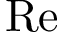<formula> <loc_0><loc_0><loc_500><loc_500>R e</formula> 